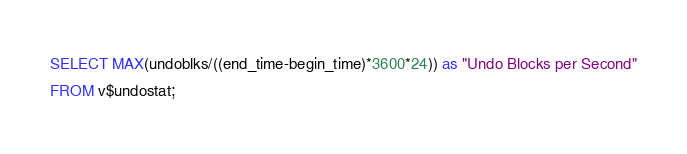<code> <loc_0><loc_0><loc_500><loc_500><_SQL_>SELECT MAX(undoblks/((end_time-begin_time)*3600*24)) as "Undo Blocks per Second"
FROM v$undostat;
</code> 